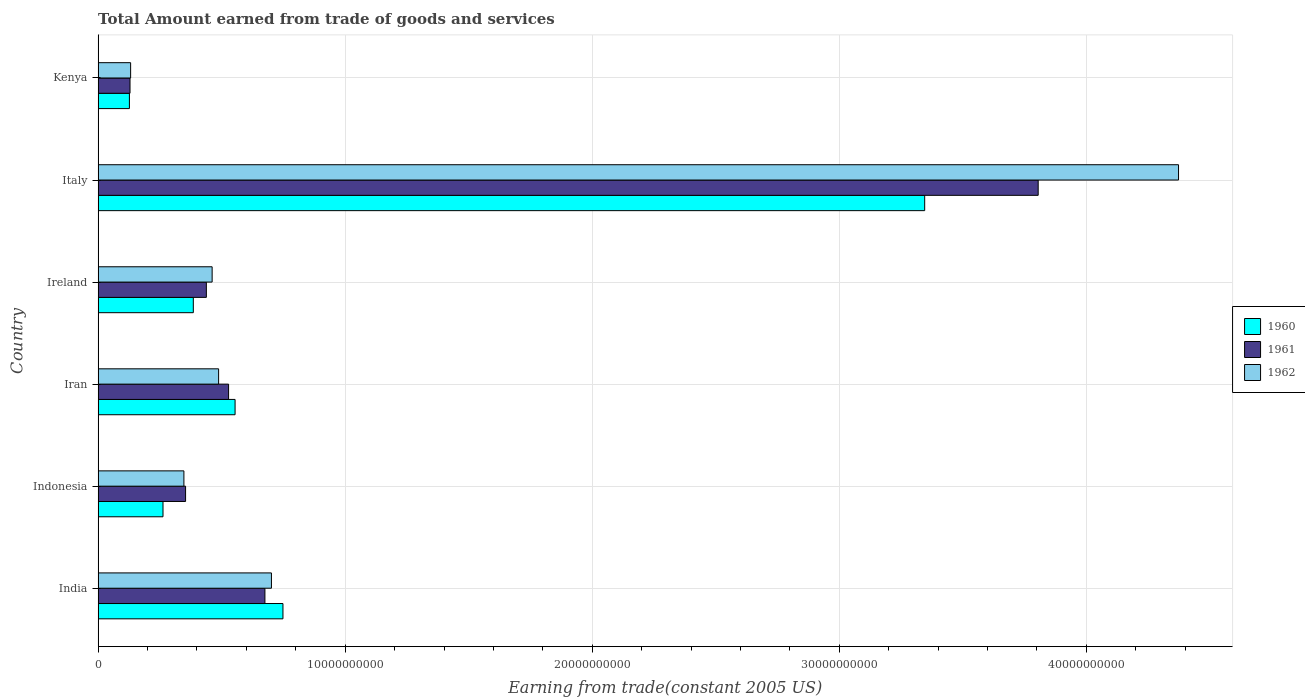How many different coloured bars are there?
Offer a terse response. 3. How many groups of bars are there?
Keep it short and to the point. 6. Are the number of bars per tick equal to the number of legend labels?
Your response must be concise. Yes. What is the label of the 5th group of bars from the top?
Provide a succinct answer. Indonesia. In how many cases, is the number of bars for a given country not equal to the number of legend labels?
Offer a terse response. 0. What is the total amount earned by trading goods and services in 1961 in India?
Your response must be concise. 6.75e+09. Across all countries, what is the maximum total amount earned by trading goods and services in 1960?
Provide a succinct answer. 3.35e+1. Across all countries, what is the minimum total amount earned by trading goods and services in 1960?
Offer a very short reply. 1.27e+09. In which country was the total amount earned by trading goods and services in 1961 maximum?
Offer a very short reply. Italy. In which country was the total amount earned by trading goods and services in 1960 minimum?
Provide a short and direct response. Kenya. What is the total total amount earned by trading goods and services in 1961 in the graph?
Make the answer very short. 5.93e+1. What is the difference between the total amount earned by trading goods and services in 1961 in Indonesia and that in Ireland?
Provide a succinct answer. -8.41e+08. What is the difference between the total amount earned by trading goods and services in 1960 in Ireland and the total amount earned by trading goods and services in 1962 in Kenya?
Offer a very short reply. 2.54e+09. What is the average total amount earned by trading goods and services in 1960 per country?
Make the answer very short. 9.04e+09. What is the difference between the total amount earned by trading goods and services in 1962 and total amount earned by trading goods and services in 1960 in Kenya?
Your response must be concise. 4.93e+07. What is the ratio of the total amount earned by trading goods and services in 1960 in India to that in Indonesia?
Ensure brevity in your answer.  2.85. What is the difference between the highest and the second highest total amount earned by trading goods and services in 1960?
Offer a very short reply. 2.60e+1. What is the difference between the highest and the lowest total amount earned by trading goods and services in 1962?
Provide a short and direct response. 4.24e+1. In how many countries, is the total amount earned by trading goods and services in 1960 greater than the average total amount earned by trading goods and services in 1960 taken over all countries?
Offer a terse response. 1. What does the 2nd bar from the top in Italy represents?
Keep it short and to the point. 1961. How many bars are there?
Your answer should be compact. 18. Are all the bars in the graph horizontal?
Ensure brevity in your answer.  Yes. How many countries are there in the graph?
Keep it short and to the point. 6. What is the difference between two consecutive major ticks on the X-axis?
Make the answer very short. 1.00e+1. Does the graph contain grids?
Your answer should be very brief. Yes. How many legend labels are there?
Your response must be concise. 3. How are the legend labels stacked?
Your answer should be very brief. Vertical. What is the title of the graph?
Your answer should be compact. Total Amount earned from trade of goods and services. Does "1985" appear as one of the legend labels in the graph?
Keep it short and to the point. No. What is the label or title of the X-axis?
Offer a very short reply. Earning from trade(constant 2005 US). What is the label or title of the Y-axis?
Offer a terse response. Country. What is the Earning from trade(constant 2005 US) in 1960 in India?
Provide a short and direct response. 7.48e+09. What is the Earning from trade(constant 2005 US) of 1961 in India?
Ensure brevity in your answer.  6.75e+09. What is the Earning from trade(constant 2005 US) in 1962 in India?
Your answer should be very brief. 7.02e+09. What is the Earning from trade(constant 2005 US) in 1960 in Indonesia?
Ensure brevity in your answer.  2.63e+09. What is the Earning from trade(constant 2005 US) of 1961 in Indonesia?
Your answer should be very brief. 3.54e+09. What is the Earning from trade(constant 2005 US) in 1962 in Indonesia?
Your answer should be very brief. 3.47e+09. What is the Earning from trade(constant 2005 US) in 1960 in Iran?
Your response must be concise. 5.54e+09. What is the Earning from trade(constant 2005 US) of 1961 in Iran?
Offer a terse response. 5.28e+09. What is the Earning from trade(constant 2005 US) of 1962 in Iran?
Offer a terse response. 4.88e+09. What is the Earning from trade(constant 2005 US) in 1960 in Ireland?
Provide a succinct answer. 3.85e+09. What is the Earning from trade(constant 2005 US) of 1961 in Ireland?
Make the answer very short. 4.38e+09. What is the Earning from trade(constant 2005 US) in 1962 in Ireland?
Ensure brevity in your answer.  4.62e+09. What is the Earning from trade(constant 2005 US) of 1960 in Italy?
Make the answer very short. 3.35e+1. What is the Earning from trade(constant 2005 US) in 1961 in Italy?
Ensure brevity in your answer.  3.81e+1. What is the Earning from trade(constant 2005 US) of 1962 in Italy?
Offer a very short reply. 4.37e+1. What is the Earning from trade(constant 2005 US) of 1960 in Kenya?
Offer a terse response. 1.27e+09. What is the Earning from trade(constant 2005 US) of 1961 in Kenya?
Provide a short and direct response. 1.29e+09. What is the Earning from trade(constant 2005 US) of 1962 in Kenya?
Keep it short and to the point. 1.32e+09. Across all countries, what is the maximum Earning from trade(constant 2005 US) in 1960?
Your answer should be compact. 3.35e+1. Across all countries, what is the maximum Earning from trade(constant 2005 US) of 1961?
Provide a succinct answer. 3.81e+1. Across all countries, what is the maximum Earning from trade(constant 2005 US) in 1962?
Provide a succinct answer. 4.37e+1. Across all countries, what is the minimum Earning from trade(constant 2005 US) in 1960?
Your answer should be very brief. 1.27e+09. Across all countries, what is the minimum Earning from trade(constant 2005 US) of 1961?
Offer a very short reply. 1.29e+09. Across all countries, what is the minimum Earning from trade(constant 2005 US) in 1962?
Your response must be concise. 1.32e+09. What is the total Earning from trade(constant 2005 US) in 1960 in the graph?
Offer a terse response. 5.42e+1. What is the total Earning from trade(constant 2005 US) in 1961 in the graph?
Your answer should be compact. 5.93e+1. What is the total Earning from trade(constant 2005 US) in 1962 in the graph?
Ensure brevity in your answer.  6.50e+1. What is the difference between the Earning from trade(constant 2005 US) of 1960 in India and that in Indonesia?
Provide a succinct answer. 4.85e+09. What is the difference between the Earning from trade(constant 2005 US) of 1961 in India and that in Indonesia?
Give a very brief answer. 3.21e+09. What is the difference between the Earning from trade(constant 2005 US) in 1962 in India and that in Indonesia?
Give a very brief answer. 3.54e+09. What is the difference between the Earning from trade(constant 2005 US) in 1960 in India and that in Iran?
Make the answer very short. 1.94e+09. What is the difference between the Earning from trade(constant 2005 US) in 1961 in India and that in Iran?
Keep it short and to the point. 1.47e+09. What is the difference between the Earning from trade(constant 2005 US) in 1962 in India and that in Iran?
Offer a very short reply. 2.14e+09. What is the difference between the Earning from trade(constant 2005 US) in 1960 in India and that in Ireland?
Make the answer very short. 3.63e+09. What is the difference between the Earning from trade(constant 2005 US) of 1961 in India and that in Ireland?
Make the answer very short. 2.37e+09. What is the difference between the Earning from trade(constant 2005 US) of 1962 in India and that in Ireland?
Your answer should be very brief. 2.40e+09. What is the difference between the Earning from trade(constant 2005 US) in 1960 in India and that in Italy?
Offer a terse response. -2.60e+1. What is the difference between the Earning from trade(constant 2005 US) of 1961 in India and that in Italy?
Your response must be concise. -3.13e+1. What is the difference between the Earning from trade(constant 2005 US) of 1962 in India and that in Italy?
Your answer should be very brief. -3.67e+1. What is the difference between the Earning from trade(constant 2005 US) in 1960 in India and that in Kenya?
Your response must be concise. 6.21e+09. What is the difference between the Earning from trade(constant 2005 US) in 1961 in India and that in Kenya?
Provide a succinct answer. 5.46e+09. What is the difference between the Earning from trade(constant 2005 US) of 1962 in India and that in Kenya?
Ensure brevity in your answer.  5.70e+09. What is the difference between the Earning from trade(constant 2005 US) in 1960 in Indonesia and that in Iran?
Provide a succinct answer. -2.92e+09. What is the difference between the Earning from trade(constant 2005 US) in 1961 in Indonesia and that in Iran?
Your answer should be very brief. -1.74e+09. What is the difference between the Earning from trade(constant 2005 US) of 1962 in Indonesia and that in Iran?
Provide a short and direct response. -1.40e+09. What is the difference between the Earning from trade(constant 2005 US) in 1960 in Indonesia and that in Ireland?
Give a very brief answer. -1.23e+09. What is the difference between the Earning from trade(constant 2005 US) in 1961 in Indonesia and that in Ireland?
Ensure brevity in your answer.  -8.41e+08. What is the difference between the Earning from trade(constant 2005 US) of 1962 in Indonesia and that in Ireland?
Offer a terse response. -1.14e+09. What is the difference between the Earning from trade(constant 2005 US) of 1960 in Indonesia and that in Italy?
Give a very brief answer. -3.08e+1. What is the difference between the Earning from trade(constant 2005 US) of 1961 in Indonesia and that in Italy?
Provide a short and direct response. -3.45e+1. What is the difference between the Earning from trade(constant 2005 US) of 1962 in Indonesia and that in Italy?
Keep it short and to the point. -4.03e+1. What is the difference between the Earning from trade(constant 2005 US) of 1960 in Indonesia and that in Kenya?
Give a very brief answer. 1.36e+09. What is the difference between the Earning from trade(constant 2005 US) of 1961 in Indonesia and that in Kenya?
Provide a succinct answer. 2.25e+09. What is the difference between the Earning from trade(constant 2005 US) of 1962 in Indonesia and that in Kenya?
Make the answer very short. 2.16e+09. What is the difference between the Earning from trade(constant 2005 US) of 1960 in Iran and that in Ireland?
Ensure brevity in your answer.  1.69e+09. What is the difference between the Earning from trade(constant 2005 US) of 1961 in Iran and that in Ireland?
Offer a very short reply. 9.00e+08. What is the difference between the Earning from trade(constant 2005 US) in 1962 in Iran and that in Ireland?
Offer a very short reply. 2.61e+08. What is the difference between the Earning from trade(constant 2005 US) of 1960 in Iran and that in Italy?
Give a very brief answer. -2.79e+1. What is the difference between the Earning from trade(constant 2005 US) in 1961 in Iran and that in Italy?
Keep it short and to the point. -3.28e+1. What is the difference between the Earning from trade(constant 2005 US) in 1962 in Iran and that in Italy?
Make the answer very short. -3.89e+1. What is the difference between the Earning from trade(constant 2005 US) in 1960 in Iran and that in Kenya?
Ensure brevity in your answer.  4.28e+09. What is the difference between the Earning from trade(constant 2005 US) of 1961 in Iran and that in Kenya?
Offer a terse response. 3.99e+09. What is the difference between the Earning from trade(constant 2005 US) of 1962 in Iran and that in Kenya?
Keep it short and to the point. 3.56e+09. What is the difference between the Earning from trade(constant 2005 US) of 1960 in Ireland and that in Italy?
Your answer should be compact. -2.96e+1. What is the difference between the Earning from trade(constant 2005 US) of 1961 in Ireland and that in Italy?
Provide a short and direct response. -3.37e+1. What is the difference between the Earning from trade(constant 2005 US) in 1962 in Ireland and that in Italy?
Ensure brevity in your answer.  -3.91e+1. What is the difference between the Earning from trade(constant 2005 US) of 1960 in Ireland and that in Kenya?
Make the answer very short. 2.59e+09. What is the difference between the Earning from trade(constant 2005 US) in 1961 in Ireland and that in Kenya?
Provide a short and direct response. 3.09e+09. What is the difference between the Earning from trade(constant 2005 US) in 1962 in Ireland and that in Kenya?
Your answer should be very brief. 3.30e+09. What is the difference between the Earning from trade(constant 2005 US) of 1960 in Italy and that in Kenya?
Your answer should be compact. 3.22e+1. What is the difference between the Earning from trade(constant 2005 US) of 1961 in Italy and that in Kenya?
Offer a terse response. 3.68e+1. What is the difference between the Earning from trade(constant 2005 US) of 1962 in Italy and that in Kenya?
Provide a succinct answer. 4.24e+1. What is the difference between the Earning from trade(constant 2005 US) of 1960 in India and the Earning from trade(constant 2005 US) of 1961 in Indonesia?
Provide a short and direct response. 3.94e+09. What is the difference between the Earning from trade(constant 2005 US) in 1960 in India and the Earning from trade(constant 2005 US) in 1962 in Indonesia?
Provide a short and direct response. 4.01e+09. What is the difference between the Earning from trade(constant 2005 US) of 1961 in India and the Earning from trade(constant 2005 US) of 1962 in Indonesia?
Offer a terse response. 3.28e+09. What is the difference between the Earning from trade(constant 2005 US) in 1960 in India and the Earning from trade(constant 2005 US) in 1961 in Iran?
Offer a terse response. 2.20e+09. What is the difference between the Earning from trade(constant 2005 US) of 1960 in India and the Earning from trade(constant 2005 US) of 1962 in Iran?
Keep it short and to the point. 2.60e+09. What is the difference between the Earning from trade(constant 2005 US) of 1961 in India and the Earning from trade(constant 2005 US) of 1962 in Iran?
Keep it short and to the point. 1.87e+09. What is the difference between the Earning from trade(constant 2005 US) of 1960 in India and the Earning from trade(constant 2005 US) of 1961 in Ireland?
Ensure brevity in your answer.  3.10e+09. What is the difference between the Earning from trade(constant 2005 US) in 1960 in India and the Earning from trade(constant 2005 US) in 1962 in Ireland?
Give a very brief answer. 2.87e+09. What is the difference between the Earning from trade(constant 2005 US) of 1961 in India and the Earning from trade(constant 2005 US) of 1962 in Ireland?
Make the answer very short. 2.14e+09. What is the difference between the Earning from trade(constant 2005 US) of 1960 in India and the Earning from trade(constant 2005 US) of 1961 in Italy?
Offer a very short reply. -3.06e+1. What is the difference between the Earning from trade(constant 2005 US) of 1960 in India and the Earning from trade(constant 2005 US) of 1962 in Italy?
Provide a succinct answer. -3.62e+1. What is the difference between the Earning from trade(constant 2005 US) of 1961 in India and the Earning from trade(constant 2005 US) of 1962 in Italy?
Make the answer very short. -3.70e+1. What is the difference between the Earning from trade(constant 2005 US) in 1960 in India and the Earning from trade(constant 2005 US) in 1961 in Kenya?
Provide a succinct answer. 6.19e+09. What is the difference between the Earning from trade(constant 2005 US) of 1960 in India and the Earning from trade(constant 2005 US) of 1962 in Kenya?
Provide a short and direct response. 6.17e+09. What is the difference between the Earning from trade(constant 2005 US) in 1961 in India and the Earning from trade(constant 2005 US) in 1962 in Kenya?
Provide a short and direct response. 5.44e+09. What is the difference between the Earning from trade(constant 2005 US) in 1960 in Indonesia and the Earning from trade(constant 2005 US) in 1961 in Iran?
Ensure brevity in your answer.  -2.65e+09. What is the difference between the Earning from trade(constant 2005 US) in 1960 in Indonesia and the Earning from trade(constant 2005 US) in 1962 in Iran?
Offer a terse response. -2.25e+09. What is the difference between the Earning from trade(constant 2005 US) in 1961 in Indonesia and the Earning from trade(constant 2005 US) in 1962 in Iran?
Your response must be concise. -1.34e+09. What is the difference between the Earning from trade(constant 2005 US) of 1960 in Indonesia and the Earning from trade(constant 2005 US) of 1961 in Ireland?
Keep it short and to the point. -1.75e+09. What is the difference between the Earning from trade(constant 2005 US) of 1960 in Indonesia and the Earning from trade(constant 2005 US) of 1962 in Ireland?
Ensure brevity in your answer.  -1.99e+09. What is the difference between the Earning from trade(constant 2005 US) in 1961 in Indonesia and the Earning from trade(constant 2005 US) in 1962 in Ireland?
Ensure brevity in your answer.  -1.08e+09. What is the difference between the Earning from trade(constant 2005 US) of 1960 in Indonesia and the Earning from trade(constant 2005 US) of 1961 in Italy?
Provide a succinct answer. -3.54e+1. What is the difference between the Earning from trade(constant 2005 US) of 1960 in Indonesia and the Earning from trade(constant 2005 US) of 1962 in Italy?
Offer a very short reply. -4.11e+1. What is the difference between the Earning from trade(constant 2005 US) of 1961 in Indonesia and the Earning from trade(constant 2005 US) of 1962 in Italy?
Make the answer very short. -4.02e+1. What is the difference between the Earning from trade(constant 2005 US) of 1960 in Indonesia and the Earning from trade(constant 2005 US) of 1961 in Kenya?
Make the answer very short. 1.33e+09. What is the difference between the Earning from trade(constant 2005 US) of 1960 in Indonesia and the Earning from trade(constant 2005 US) of 1962 in Kenya?
Make the answer very short. 1.31e+09. What is the difference between the Earning from trade(constant 2005 US) in 1961 in Indonesia and the Earning from trade(constant 2005 US) in 1962 in Kenya?
Make the answer very short. 2.22e+09. What is the difference between the Earning from trade(constant 2005 US) in 1960 in Iran and the Earning from trade(constant 2005 US) in 1961 in Ireland?
Keep it short and to the point. 1.16e+09. What is the difference between the Earning from trade(constant 2005 US) of 1960 in Iran and the Earning from trade(constant 2005 US) of 1962 in Ireland?
Provide a short and direct response. 9.28e+08. What is the difference between the Earning from trade(constant 2005 US) of 1961 in Iran and the Earning from trade(constant 2005 US) of 1962 in Ireland?
Make the answer very short. 6.65e+08. What is the difference between the Earning from trade(constant 2005 US) in 1960 in Iran and the Earning from trade(constant 2005 US) in 1961 in Italy?
Provide a succinct answer. -3.25e+1. What is the difference between the Earning from trade(constant 2005 US) in 1960 in Iran and the Earning from trade(constant 2005 US) in 1962 in Italy?
Ensure brevity in your answer.  -3.82e+1. What is the difference between the Earning from trade(constant 2005 US) in 1961 in Iran and the Earning from trade(constant 2005 US) in 1962 in Italy?
Make the answer very short. -3.85e+1. What is the difference between the Earning from trade(constant 2005 US) in 1960 in Iran and the Earning from trade(constant 2005 US) in 1961 in Kenya?
Offer a terse response. 4.25e+09. What is the difference between the Earning from trade(constant 2005 US) of 1960 in Iran and the Earning from trade(constant 2005 US) of 1962 in Kenya?
Give a very brief answer. 4.23e+09. What is the difference between the Earning from trade(constant 2005 US) of 1961 in Iran and the Earning from trade(constant 2005 US) of 1962 in Kenya?
Ensure brevity in your answer.  3.96e+09. What is the difference between the Earning from trade(constant 2005 US) of 1960 in Ireland and the Earning from trade(constant 2005 US) of 1961 in Italy?
Keep it short and to the point. -3.42e+1. What is the difference between the Earning from trade(constant 2005 US) of 1960 in Ireland and the Earning from trade(constant 2005 US) of 1962 in Italy?
Provide a succinct answer. -3.99e+1. What is the difference between the Earning from trade(constant 2005 US) of 1961 in Ireland and the Earning from trade(constant 2005 US) of 1962 in Italy?
Give a very brief answer. -3.93e+1. What is the difference between the Earning from trade(constant 2005 US) in 1960 in Ireland and the Earning from trade(constant 2005 US) in 1961 in Kenya?
Provide a succinct answer. 2.56e+09. What is the difference between the Earning from trade(constant 2005 US) of 1960 in Ireland and the Earning from trade(constant 2005 US) of 1962 in Kenya?
Ensure brevity in your answer.  2.54e+09. What is the difference between the Earning from trade(constant 2005 US) in 1961 in Ireland and the Earning from trade(constant 2005 US) in 1962 in Kenya?
Your answer should be very brief. 3.07e+09. What is the difference between the Earning from trade(constant 2005 US) in 1960 in Italy and the Earning from trade(constant 2005 US) in 1961 in Kenya?
Your answer should be very brief. 3.22e+1. What is the difference between the Earning from trade(constant 2005 US) in 1960 in Italy and the Earning from trade(constant 2005 US) in 1962 in Kenya?
Offer a terse response. 3.21e+1. What is the difference between the Earning from trade(constant 2005 US) in 1961 in Italy and the Earning from trade(constant 2005 US) in 1962 in Kenya?
Offer a terse response. 3.67e+1. What is the average Earning from trade(constant 2005 US) of 1960 per country?
Keep it short and to the point. 9.04e+09. What is the average Earning from trade(constant 2005 US) of 1961 per country?
Give a very brief answer. 9.88e+09. What is the average Earning from trade(constant 2005 US) of 1962 per country?
Provide a succinct answer. 1.08e+1. What is the difference between the Earning from trade(constant 2005 US) in 1960 and Earning from trade(constant 2005 US) in 1961 in India?
Your response must be concise. 7.30e+08. What is the difference between the Earning from trade(constant 2005 US) of 1960 and Earning from trade(constant 2005 US) of 1962 in India?
Give a very brief answer. 4.66e+08. What is the difference between the Earning from trade(constant 2005 US) in 1961 and Earning from trade(constant 2005 US) in 1962 in India?
Provide a short and direct response. -2.64e+08. What is the difference between the Earning from trade(constant 2005 US) in 1960 and Earning from trade(constant 2005 US) in 1961 in Indonesia?
Offer a very short reply. -9.14e+08. What is the difference between the Earning from trade(constant 2005 US) of 1960 and Earning from trade(constant 2005 US) of 1962 in Indonesia?
Make the answer very short. -8.46e+08. What is the difference between the Earning from trade(constant 2005 US) in 1961 and Earning from trade(constant 2005 US) in 1962 in Indonesia?
Keep it short and to the point. 6.82e+07. What is the difference between the Earning from trade(constant 2005 US) in 1960 and Earning from trade(constant 2005 US) in 1961 in Iran?
Offer a very short reply. 2.63e+08. What is the difference between the Earning from trade(constant 2005 US) of 1960 and Earning from trade(constant 2005 US) of 1962 in Iran?
Provide a short and direct response. 6.67e+08. What is the difference between the Earning from trade(constant 2005 US) of 1961 and Earning from trade(constant 2005 US) of 1962 in Iran?
Your answer should be very brief. 4.04e+08. What is the difference between the Earning from trade(constant 2005 US) of 1960 and Earning from trade(constant 2005 US) of 1961 in Ireland?
Provide a short and direct response. -5.28e+08. What is the difference between the Earning from trade(constant 2005 US) of 1960 and Earning from trade(constant 2005 US) of 1962 in Ireland?
Make the answer very short. -7.62e+08. What is the difference between the Earning from trade(constant 2005 US) in 1961 and Earning from trade(constant 2005 US) in 1962 in Ireland?
Offer a terse response. -2.34e+08. What is the difference between the Earning from trade(constant 2005 US) of 1960 and Earning from trade(constant 2005 US) of 1961 in Italy?
Keep it short and to the point. -4.59e+09. What is the difference between the Earning from trade(constant 2005 US) in 1960 and Earning from trade(constant 2005 US) in 1962 in Italy?
Offer a very short reply. -1.03e+1. What is the difference between the Earning from trade(constant 2005 US) in 1961 and Earning from trade(constant 2005 US) in 1962 in Italy?
Make the answer very short. -5.68e+09. What is the difference between the Earning from trade(constant 2005 US) of 1960 and Earning from trade(constant 2005 US) of 1961 in Kenya?
Provide a short and direct response. -2.47e+07. What is the difference between the Earning from trade(constant 2005 US) of 1960 and Earning from trade(constant 2005 US) of 1962 in Kenya?
Offer a terse response. -4.93e+07. What is the difference between the Earning from trade(constant 2005 US) of 1961 and Earning from trade(constant 2005 US) of 1962 in Kenya?
Your answer should be compact. -2.46e+07. What is the ratio of the Earning from trade(constant 2005 US) in 1960 in India to that in Indonesia?
Offer a terse response. 2.85. What is the ratio of the Earning from trade(constant 2005 US) of 1961 in India to that in Indonesia?
Make the answer very short. 1.91. What is the ratio of the Earning from trade(constant 2005 US) of 1962 in India to that in Indonesia?
Provide a short and direct response. 2.02. What is the ratio of the Earning from trade(constant 2005 US) in 1960 in India to that in Iran?
Provide a succinct answer. 1.35. What is the ratio of the Earning from trade(constant 2005 US) of 1961 in India to that in Iran?
Your answer should be compact. 1.28. What is the ratio of the Earning from trade(constant 2005 US) of 1962 in India to that in Iran?
Make the answer very short. 1.44. What is the ratio of the Earning from trade(constant 2005 US) of 1960 in India to that in Ireland?
Provide a short and direct response. 1.94. What is the ratio of the Earning from trade(constant 2005 US) in 1961 in India to that in Ireland?
Keep it short and to the point. 1.54. What is the ratio of the Earning from trade(constant 2005 US) of 1962 in India to that in Ireland?
Your answer should be very brief. 1.52. What is the ratio of the Earning from trade(constant 2005 US) in 1960 in India to that in Italy?
Your response must be concise. 0.22. What is the ratio of the Earning from trade(constant 2005 US) in 1961 in India to that in Italy?
Provide a short and direct response. 0.18. What is the ratio of the Earning from trade(constant 2005 US) of 1962 in India to that in Italy?
Your answer should be compact. 0.16. What is the ratio of the Earning from trade(constant 2005 US) in 1960 in India to that in Kenya?
Give a very brief answer. 5.91. What is the ratio of the Earning from trade(constant 2005 US) of 1961 in India to that in Kenya?
Offer a very short reply. 5.23. What is the ratio of the Earning from trade(constant 2005 US) of 1962 in India to that in Kenya?
Offer a terse response. 5.33. What is the ratio of the Earning from trade(constant 2005 US) of 1960 in Indonesia to that in Iran?
Give a very brief answer. 0.47. What is the ratio of the Earning from trade(constant 2005 US) of 1961 in Indonesia to that in Iran?
Offer a very short reply. 0.67. What is the ratio of the Earning from trade(constant 2005 US) of 1962 in Indonesia to that in Iran?
Offer a terse response. 0.71. What is the ratio of the Earning from trade(constant 2005 US) in 1960 in Indonesia to that in Ireland?
Offer a terse response. 0.68. What is the ratio of the Earning from trade(constant 2005 US) of 1961 in Indonesia to that in Ireland?
Your response must be concise. 0.81. What is the ratio of the Earning from trade(constant 2005 US) of 1962 in Indonesia to that in Ireland?
Offer a very short reply. 0.75. What is the ratio of the Earning from trade(constant 2005 US) of 1960 in Indonesia to that in Italy?
Your answer should be very brief. 0.08. What is the ratio of the Earning from trade(constant 2005 US) in 1961 in Indonesia to that in Italy?
Provide a short and direct response. 0.09. What is the ratio of the Earning from trade(constant 2005 US) of 1962 in Indonesia to that in Italy?
Make the answer very short. 0.08. What is the ratio of the Earning from trade(constant 2005 US) of 1960 in Indonesia to that in Kenya?
Ensure brevity in your answer.  2.07. What is the ratio of the Earning from trade(constant 2005 US) in 1961 in Indonesia to that in Kenya?
Offer a terse response. 2.74. What is the ratio of the Earning from trade(constant 2005 US) of 1962 in Indonesia to that in Kenya?
Provide a short and direct response. 2.64. What is the ratio of the Earning from trade(constant 2005 US) in 1960 in Iran to that in Ireland?
Your response must be concise. 1.44. What is the ratio of the Earning from trade(constant 2005 US) of 1961 in Iran to that in Ireland?
Your response must be concise. 1.21. What is the ratio of the Earning from trade(constant 2005 US) in 1962 in Iran to that in Ireland?
Your answer should be compact. 1.06. What is the ratio of the Earning from trade(constant 2005 US) of 1960 in Iran to that in Italy?
Your answer should be compact. 0.17. What is the ratio of the Earning from trade(constant 2005 US) of 1961 in Iran to that in Italy?
Make the answer very short. 0.14. What is the ratio of the Earning from trade(constant 2005 US) of 1962 in Iran to that in Italy?
Offer a very short reply. 0.11. What is the ratio of the Earning from trade(constant 2005 US) in 1960 in Iran to that in Kenya?
Ensure brevity in your answer.  4.38. What is the ratio of the Earning from trade(constant 2005 US) in 1961 in Iran to that in Kenya?
Give a very brief answer. 4.09. What is the ratio of the Earning from trade(constant 2005 US) of 1962 in Iran to that in Kenya?
Ensure brevity in your answer.  3.71. What is the ratio of the Earning from trade(constant 2005 US) in 1960 in Ireland to that in Italy?
Keep it short and to the point. 0.12. What is the ratio of the Earning from trade(constant 2005 US) of 1961 in Ireland to that in Italy?
Offer a terse response. 0.12. What is the ratio of the Earning from trade(constant 2005 US) in 1962 in Ireland to that in Italy?
Offer a terse response. 0.11. What is the ratio of the Earning from trade(constant 2005 US) of 1960 in Ireland to that in Kenya?
Your answer should be very brief. 3.04. What is the ratio of the Earning from trade(constant 2005 US) of 1961 in Ireland to that in Kenya?
Offer a very short reply. 3.39. What is the ratio of the Earning from trade(constant 2005 US) in 1962 in Ireland to that in Kenya?
Give a very brief answer. 3.51. What is the ratio of the Earning from trade(constant 2005 US) in 1960 in Italy to that in Kenya?
Ensure brevity in your answer.  26.41. What is the ratio of the Earning from trade(constant 2005 US) in 1961 in Italy to that in Kenya?
Give a very brief answer. 29.47. What is the ratio of the Earning from trade(constant 2005 US) in 1962 in Italy to that in Kenya?
Provide a succinct answer. 33.23. What is the difference between the highest and the second highest Earning from trade(constant 2005 US) of 1960?
Make the answer very short. 2.60e+1. What is the difference between the highest and the second highest Earning from trade(constant 2005 US) of 1961?
Make the answer very short. 3.13e+1. What is the difference between the highest and the second highest Earning from trade(constant 2005 US) in 1962?
Your answer should be compact. 3.67e+1. What is the difference between the highest and the lowest Earning from trade(constant 2005 US) of 1960?
Offer a terse response. 3.22e+1. What is the difference between the highest and the lowest Earning from trade(constant 2005 US) in 1961?
Provide a short and direct response. 3.68e+1. What is the difference between the highest and the lowest Earning from trade(constant 2005 US) in 1962?
Offer a terse response. 4.24e+1. 